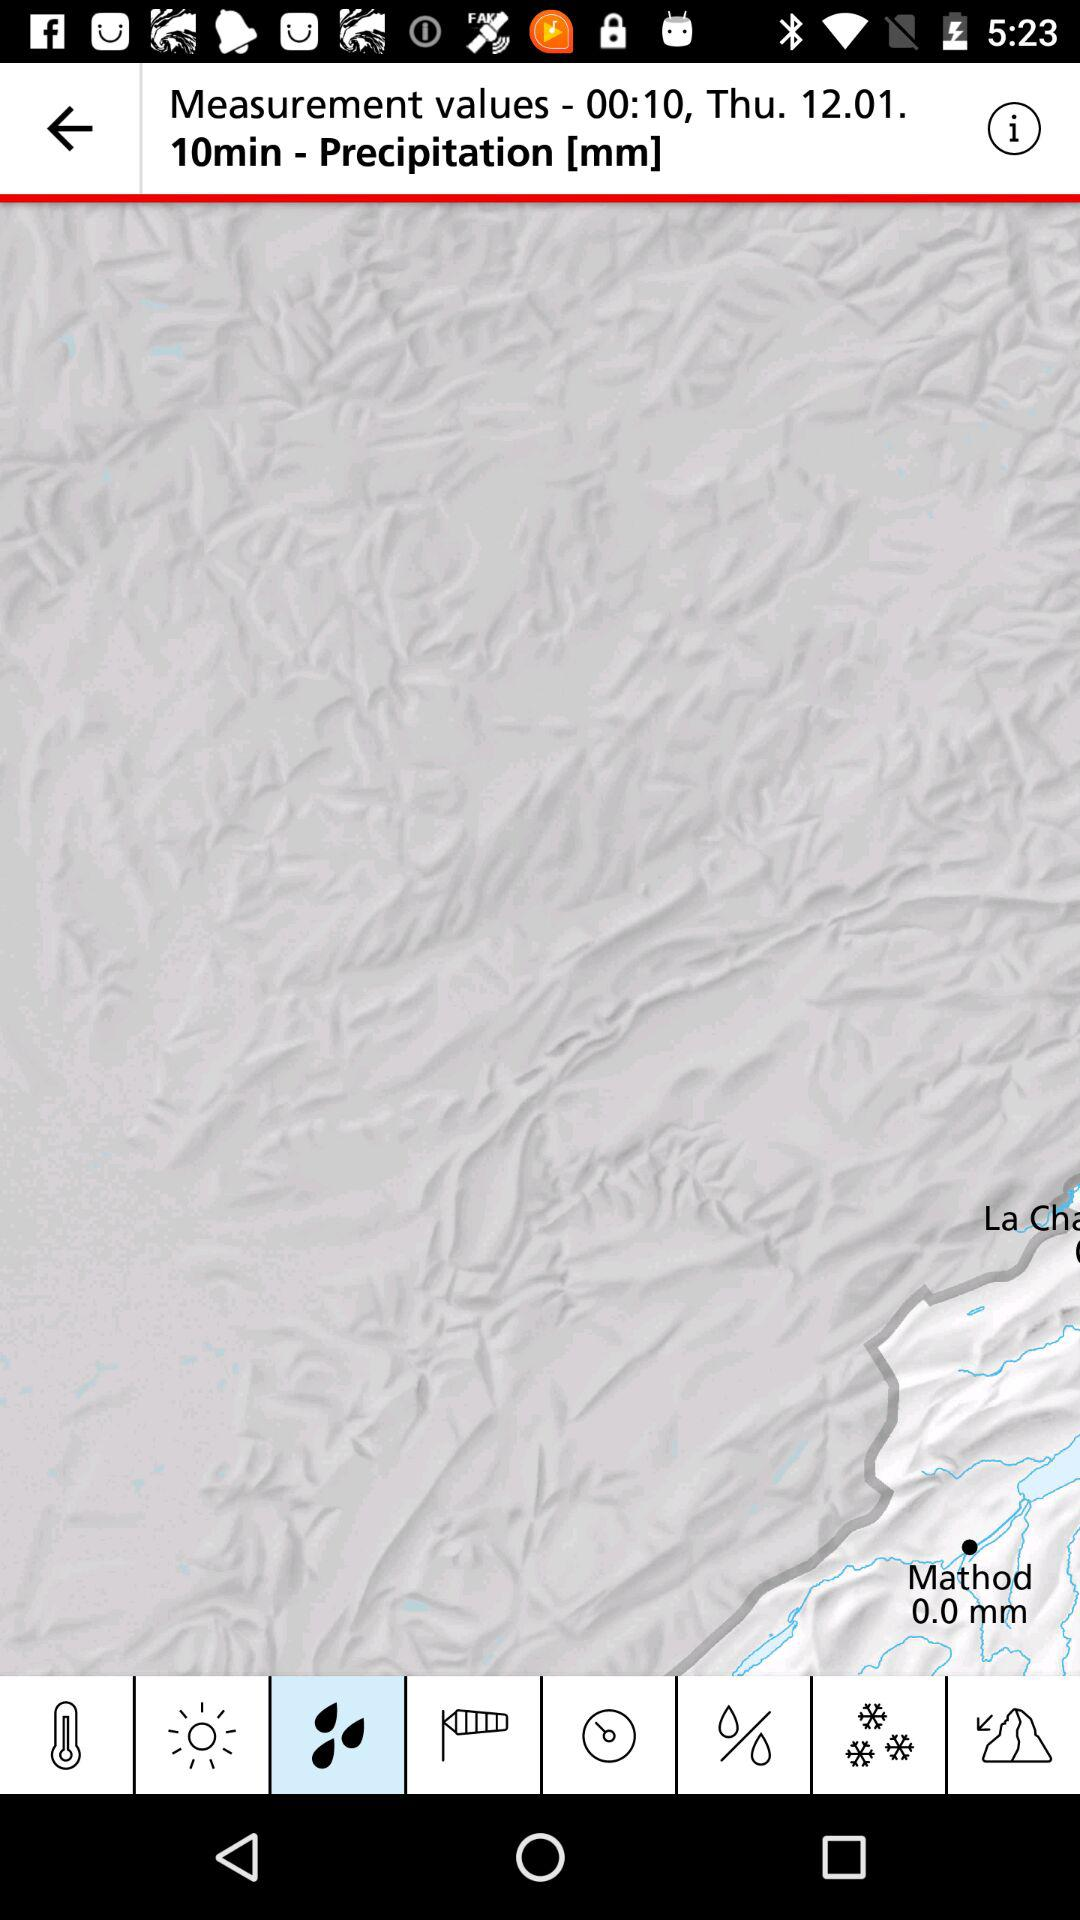What is the precipitation duration? The precipitation duration is 10 minutes. 